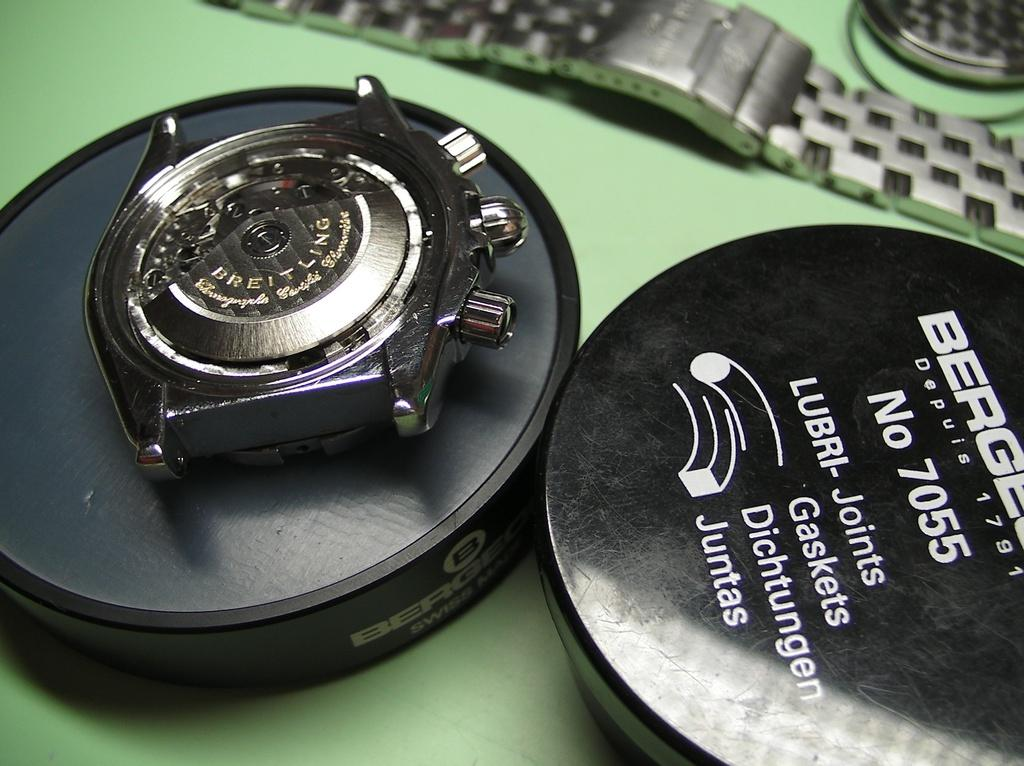<image>
Describe the image concisely. A watch is next to a black container that says "LUBRI - Joints". 